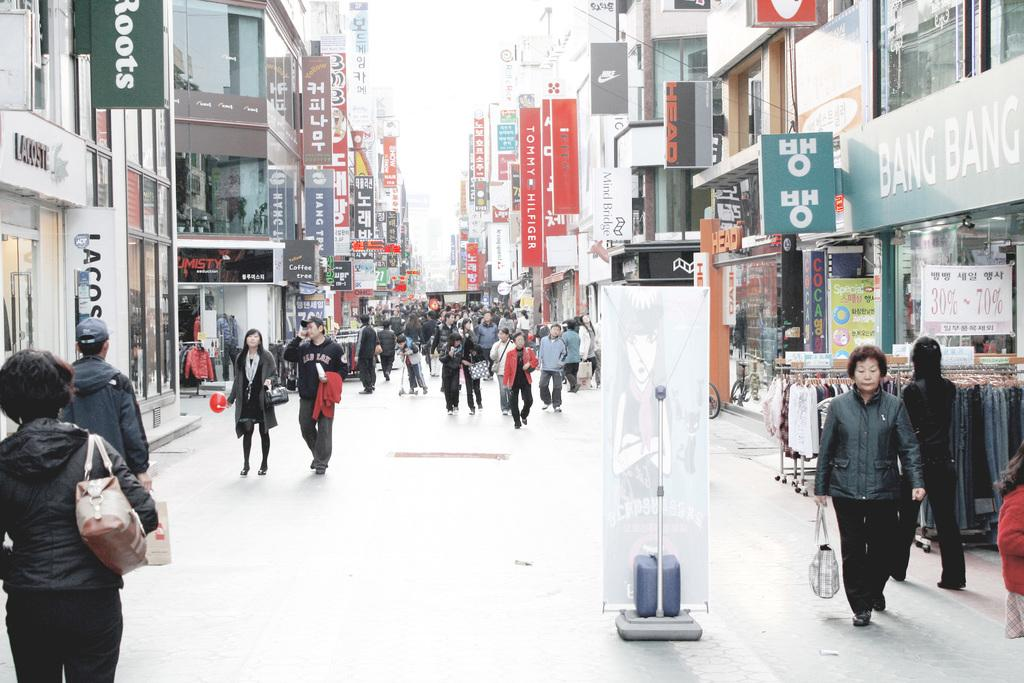What are the people in the image doing? The people in the image are walking down the street. What can be seen on either side of the street in the image? There are shops on either side of the street in the image. What type of gold patch can be seen on the plough in the image? There is no gold patch or plough present in the image; it features people walking down the street with shops on either side. 